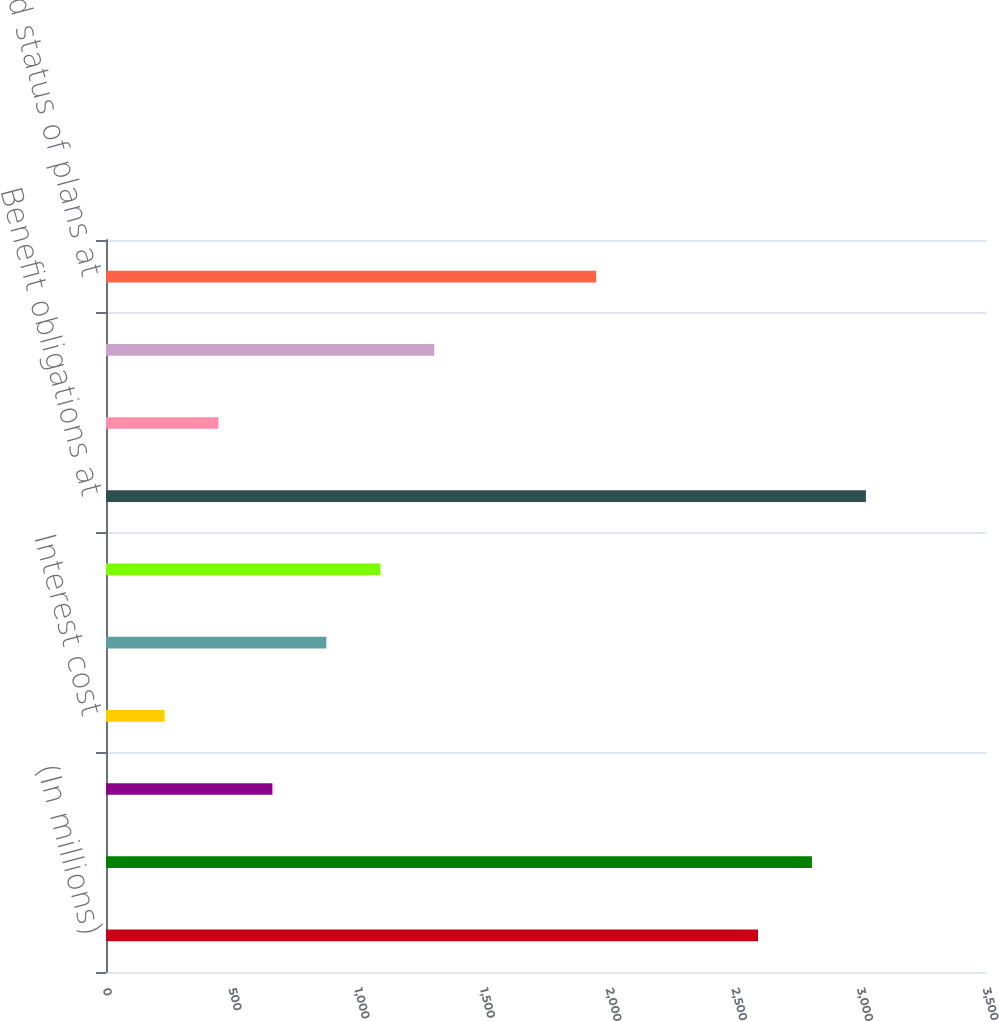Convert chart. <chart><loc_0><loc_0><loc_500><loc_500><bar_chart><fcel>(In millions)<fcel>Benefit obligations at January<fcel>Service cost<fcel>Interest cost<fcel>Actuarial (gain) loss<fcel>Benefits paid<fcel>Benefit obligations at<fcel>Employer contributions<fcel>Benefits paid from plan assets<fcel>Funded status of plans at<nl><fcel>2593.2<fcel>2807.8<fcel>661.8<fcel>232.6<fcel>876.4<fcel>1091<fcel>3022.4<fcel>447.2<fcel>1305.6<fcel>1949.4<nl></chart> 